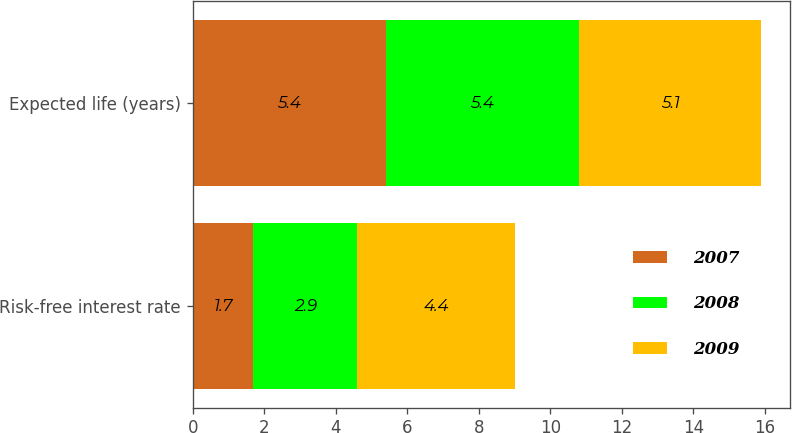Convert chart to OTSL. <chart><loc_0><loc_0><loc_500><loc_500><stacked_bar_chart><ecel><fcel>Risk-free interest rate<fcel>Expected life (years)<nl><fcel>2007<fcel>1.7<fcel>5.4<nl><fcel>2008<fcel>2.9<fcel>5.4<nl><fcel>2009<fcel>4.4<fcel>5.1<nl></chart> 